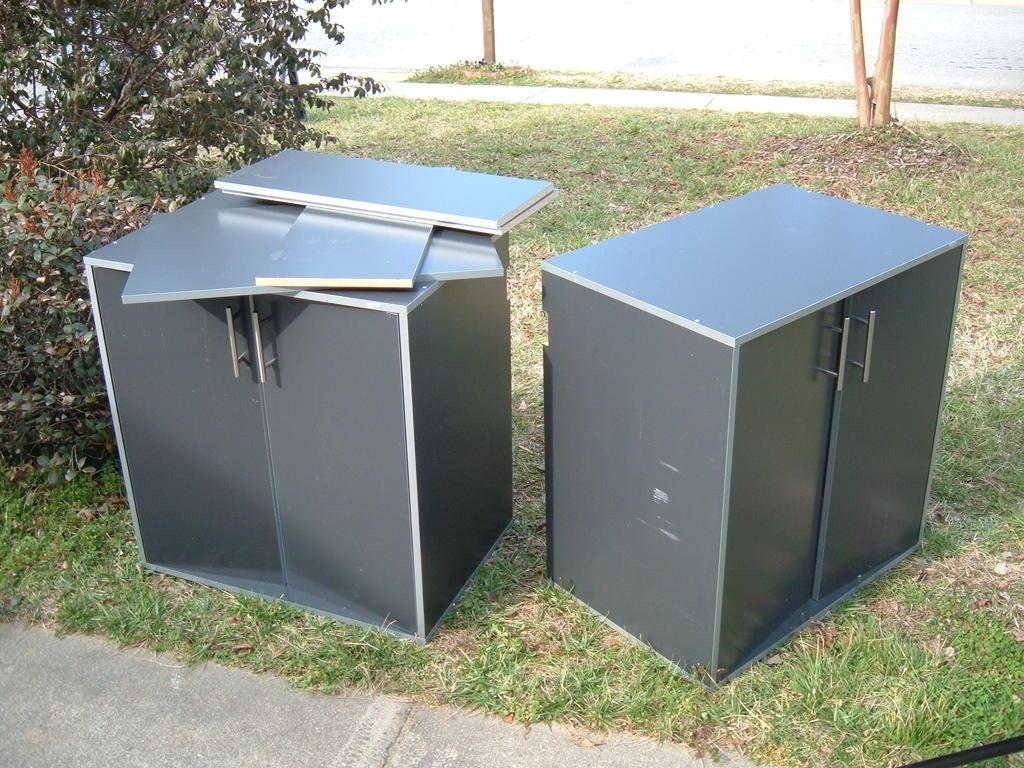How many wardrobes are present in the image? There are two small wardrobes in the image. Where are the wardrobes located? The wardrobes are on the grass. What can be seen in the background of the image? There are trees visible in the image. Is there any indication of a path or walkway in the image? Yes, there is a path in the image. Can you see any baby deer playing with toys on the path in the image? There are no baby deer or toys present in the image; it features two small wardrobes on the grass, trees in the background, and a path. 